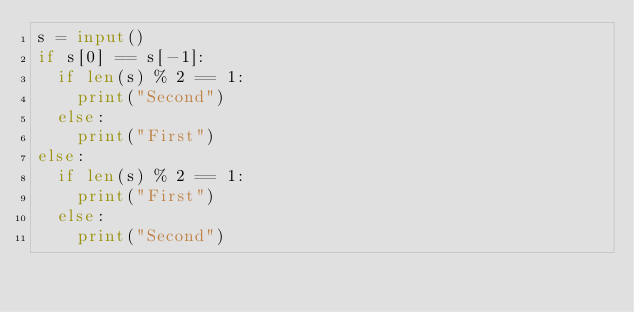Convert code to text. <code><loc_0><loc_0><loc_500><loc_500><_Python_>s = input()
if s[0] == s[-1]:
  if len(s) % 2 == 1:
    print("Second")
  else:
    print("First")
else:
  if len(s) % 2 == 1:
    print("First")
  else:
    print("Second")
</code> 